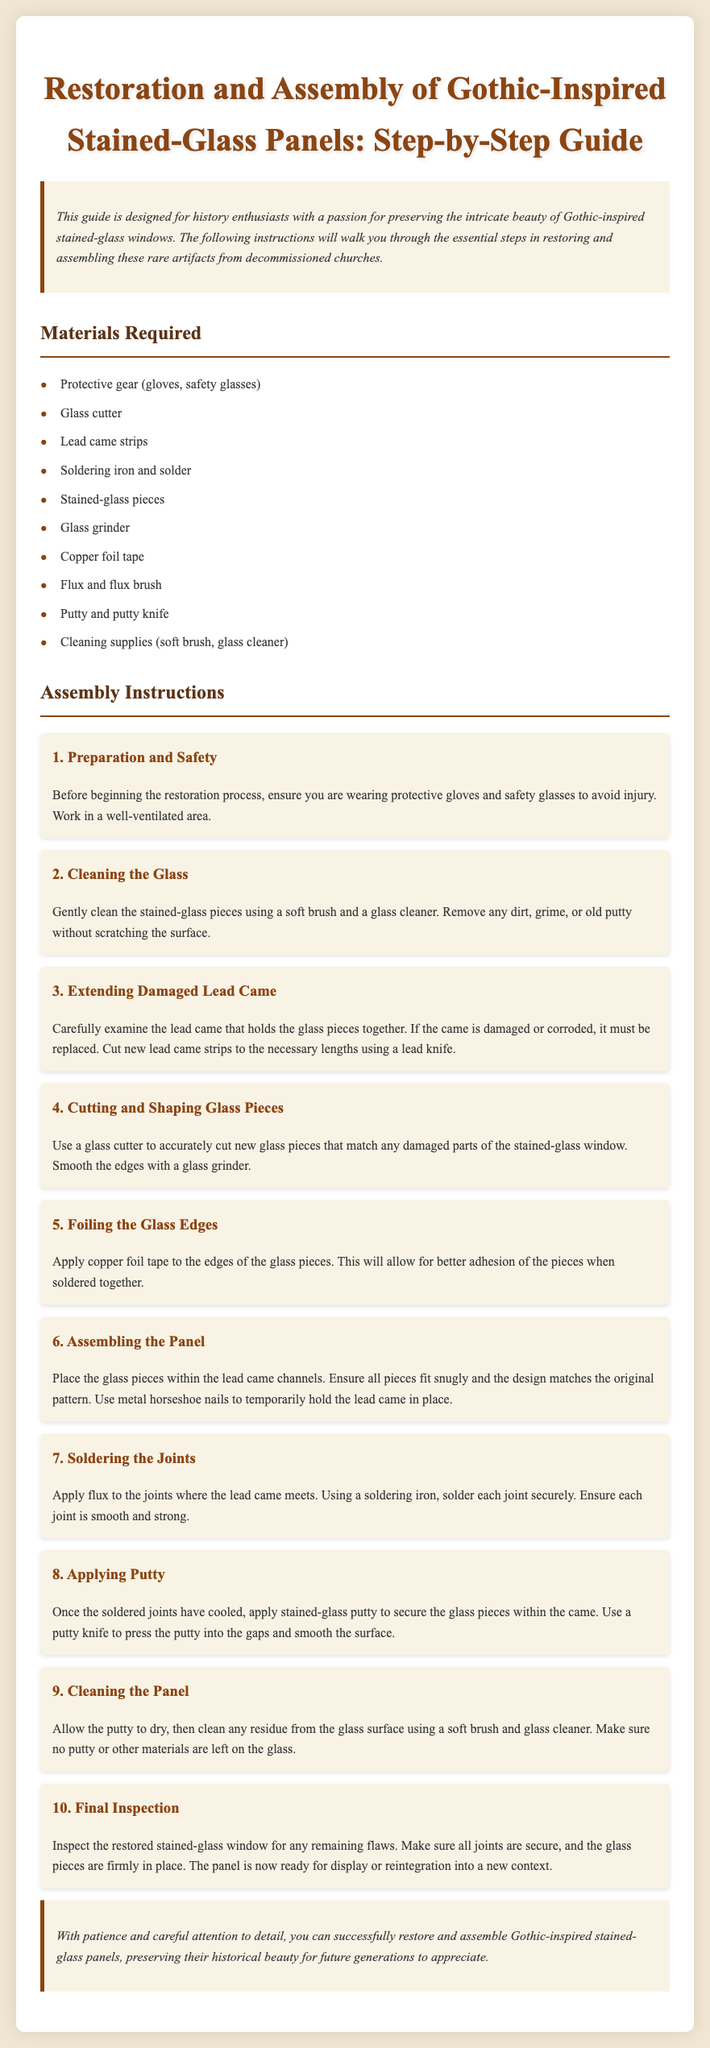What is the title of the guide? The title of the guide is provided at the top of the document, which focuses on stained-glass restoration and assembly instructions.
Answer: Restoration and Assembly of Gothic-Inspired Stained-Glass Panels: Step-by-Step Guide What is the first step in the assembly instructions? The first step is clearly outlined in the instructions, detailing initial preparations necessary for safety.
Answer: Preparation and Safety How many materials are listed as required? The document contains a specific section that enumerates all necessary materials for the restoration process.
Answer: Ten What is applied to the glass edges before assembling the panel? The process detailed specifies a particular material that needs to be used before placing glass pieces together.
Answer: Copper foil tape What should you do if the lead came is damaged? The instructions indicate a specific action that must be taken to address issues with the lead came during restoration.
Answer: Replace it What is done after soldering the joints? There is a straightforward sequence of actions to follow after soldering that is mentioned in the assembly instructions.
Answer: Apply Putty In which area should you work during the restoration? The guide recommends a particular type of environment to ensure safety and efficiency during the restoration process.
Answer: Well-ventilated area What is used to hold the lead came in place temporarily? The document specifies a particular item to secure the lead came temporarily during assembly.
Answer: Metal horseshoe nails How should the glass pieces be cleaned prior to assembly? The cleaning method described involves using specific tools and materials to maintain the integrity of the glass.
Answer: Soft brush and glass cleaner 